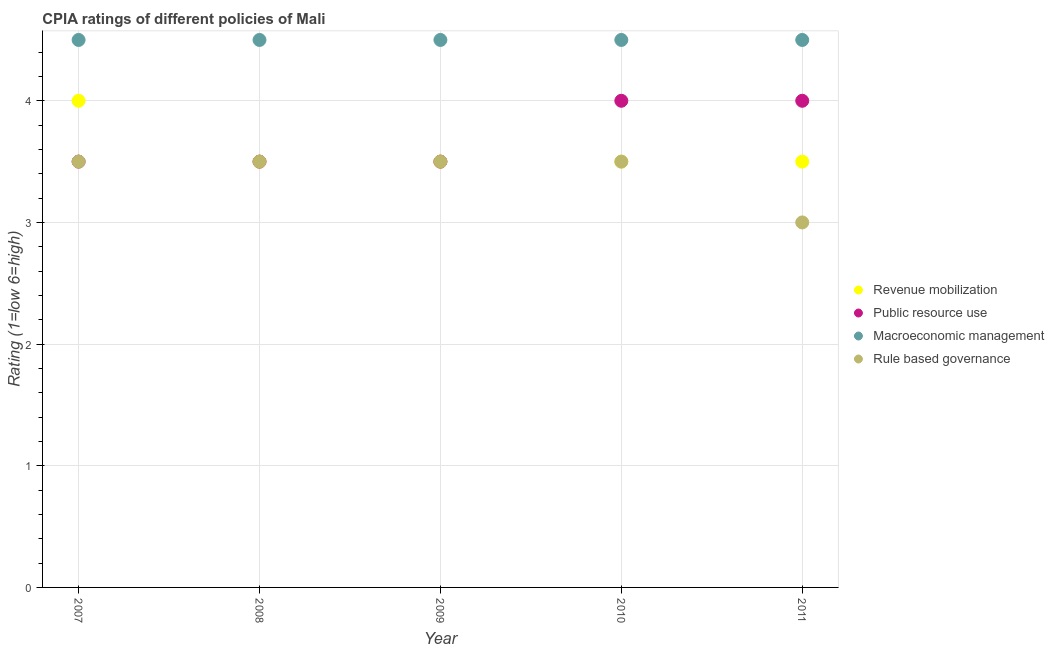What is the cpia rating of revenue mobilization in 2008?
Offer a terse response. 3.5. In which year was the cpia rating of public resource use maximum?
Make the answer very short. 2010. In which year was the cpia rating of macroeconomic management minimum?
Your answer should be very brief. 2007. What is the total cpia rating of revenue mobilization in the graph?
Give a very brief answer. 18. What is the average cpia rating of rule based governance per year?
Provide a short and direct response. 3.4. In the year 2011, what is the difference between the cpia rating of public resource use and cpia rating of macroeconomic management?
Ensure brevity in your answer.  -0.5. Is the cpia rating of public resource use in 2010 less than that in 2011?
Your response must be concise. No. Is the difference between the cpia rating of public resource use in 2008 and 2009 greater than the difference between the cpia rating of rule based governance in 2008 and 2009?
Give a very brief answer. No. What is the difference between the highest and the second highest cpia rating of public resource use?
Make the answer very short. 0. In how many years, is the cpia rating of macroeconomic management greater than the average cpia rating of macroeconomic management taken over all years?
Give a very brief answer. 0. Is the sum of the cpia rating of public resource use in 2009 and 2010 greater than the maximum cpia rating of revenue mobilization across all years?
Provide a short and direct response. Yes. Is it the case that in every year, the sum of the cpia rating of revenue mobilization and cpia rating of public resource use is greater than the cpia rating of macroeconomic management?
Your answer should be very brief. Yes. Is the cpia rating of rule based governance strictly less than the cpia rating of revenue mobilization over the years?
Provide a short and direct response. No. Are the values on the major ticks of Y-axis written in scientific E-notation?
Your answer should be compact. No. Where does the legend appear in the graph?
Make the answer very short. Center right. What is the title of the graph?
Offer a very short reply. CPIA ratings of different policies of Mali. Does "Third 20% of population" appear as one of the legend labels in the graph?
Provide a succinct answer. No. What is the label or title of the X-axis?
Offer a very short reply. Year. What is the label or title of the Y-axis?
Your answer should be compact. Rating (1=low 6=high). What is the Rating (1=low 6=high) of Revenue mobilization in 2007?
Your answer should be compact. 4. What is the Rating (1=low 6=high) in Public resource use in 2007?
Make the answer very short. 3.5. What is the Rating (1=low 6=high) of Macroeconomic management in 2007?
Provide a succinct answer. 4.5. What is the Rating (1=low 6=high) of Rule based governance in 2007?
Your response must be concise. 3.5. What is the Rating (1=low 6=high) in Revenue mobilization in 2008?
Provide a succinct answer. 3.5. What is the Rating (1=low 6=high) of Macroeconomic management in 2008?
Give a very brief answer. 4.5. What is the Rating (1=low 6=high) in Rule based governance in 2008?
Offer a very short reply. 3.5. What is the Rating (1=low 6=high) in Revenue mobilization in 2009?
Ensure brevity in your answer.  3.5. What is the Rating (1=low 6=high) in Public resource use in 2009?
Give a very brief answer. 3.5. What is the Rating (1=low 6=high) of Public resource use in 2010?
Make the answer very short. 4. What is the Rating (1=low 6=high) in Macroeconomic management in 2010?
Offer a terse response. 4.5. What is the Rating (1=low 6=high) in Rule based governance in 2010?
Your answer should be compact. 3.5. What is the Rating (1=low 6=high) in Macroeconomic management in 2011?
Your answer should be very brief. 4.5. Across all years, what is the maximum Rating (1=low 6=high) in Revenue mobilization?
Provide a short and direct response. 4. Across all years, what is the maximum Rating (1=low 6=high) in Public resource use?
Your answer should be very brief. 4. Across all years, what is the maximum Rating (1=low 6=high) in Rule based governance?
Provide a short and direct response. 3.5. Across all years, what is the minimum Rating (1=low 6=high) of Public resource use?
Your response must be concise. 3.5. Across all years, what is the minimum Rating (1=low 6=high) in Macroeconomic management?
Your answer should be compact. 4.5. What is the total Rating (1=low 6=high) of Macroeconomic management in the graph?
Keep it short and to the point. 22.5. What is the total Rating (1=low 6=high) of Rule based governance in the graph?
Your response must be concise. 17. What is the difference between the Rating (1=low 6=high) of Revenue mobilization in 2007 and that in 2008?
Your answer should be very brief. 0.5. What is the difference between the Rating (1=low 6=high) of Public resource use in 2007 and that in 2008?
Keep it short and to the point. 0. What is the difference between the Rating (1=low 6=high) of Rule based governance in 2007 and that in 2008?
Your response must be concise. 0. What is the difference between the Rating (1=low 6=high) in Revenue mobilization in 2007 and that in 2009?
Give a very brief answer. 0.5. What is the difference between the Rating (1=low 6=high) in Public resource use in 2007 and that in 2009?
Your answer should be very brief. 0. What is the difference between the Rating (1=low 6=high) in Macroeconomic management in 2007 and that in 2009?
Your response must be concise. 0. What is the difference between the Rating (1=low 6=high) of Rule based governance in 2007 and that in 2009?
Offer a terse response. 0. What is the difference between the Rating (1=low 6=high) in Public resource use in 2007 and that in 2010?
Keep it short and to the point. -0.5. What is the difference between the Rating (1=low 6=high) in Macroeconomic management in 2007 and that in 2010?
Your response must be concise. 0. What is the difference between the Rating (1=low 6=high) in Revenue mobilization in 2007 and that in 2011?
Provide a succinct answer. 0.5. What is the difference between the Rating (1=low 6=high) in Public resource use in 2007 and that in 2011?
Your response must be concise. -0.5. What is the difference between the Rating (1=low 6=high) of Revenue mobilization in 2008 and that in 2009?
Your answer should be very brief. 0. What is the difference between the Rating (1=low 6=high) of Public resource use in 2008 and that in 2009?
Your answer should be very brief. 0. What is the difference between the Rating (1=low 6=high) of Macroeconomic management in 2008 and that in 2009?
Offer a terse response. 0. What is the difference between the Rating (1=low 6=high) in Rule based governance in 2008 and that in 2009?
Provide a succinct answer. 0. What is the difference between the Rating (1=low 6=high) of Public resource use in 2008 and that in 2010?
Offer a terse response. -0.5. What is the difference between the Rating (1=low 6=high) of Macroeconomic management in 2008 and that in 2010?
Provide a short and direct response. 0. What is the difference between the Rating (1=low 6=high) of Public resource use in 2008 and that in 2011?
Provide a succinct answer. -0.5. What is the difference between the Rating (1=low 6=high) of Revenue mobilization in 2009 and that in 2010?
Your answer should be compact. 0. What is the difference between the Rating (1=low 6=high) in Public resource use in 2009 and that in 2010?
Your answer should be very brief. -0.5. What is the difference between the Rating (1=low 6=high) in Rule based governance in 2009 and that in 2010?
Provide a succinct answer. 0. What is the difference between the Rating (1=low 6=high) of Revenue mobilization in 2009 and that in 2011?
Make the answer very short. 0. What is the difference between the Rating (1=low 6=high) of Rule based governance in 2010 and that in 2011?
Ensure brevity in your answer.  0.5. What is the difference between the Rating (1=low 6=high) of Revenue mobilization in 2007 and the Rating (1=low 6=high) of Macroeconomic management in 2008?
Your answer should be compact. -0.5. What is the difference between the Rating (1=low 6=high) of Public resource use in 2007 and the Rating (1=low 6=high) of Macroeconomic management in 2008?
Your answer should be very brief. -1. What is the difference between the Rating (1=low 6=high) of Macroeconomic management in 2007 and the Rating (1=low 6=high) of Rule based governance in 2008?
Your answer should be very brief. 1. What is the difference between the Rating (1=low 6=high) of Revenue mobilization in 2007 and the Rating (1=low 6=high) of Public resource use in 2009?
Keep it short and to the point. 0.5. What is the difference between the Rating (1=low 6=high) of Public resource use in 2007 and the Rating (1=low 6=high) of Macroeconomic management in 2009?
Provide a short and direct response. -1. What is the difference between the Rating (1=low 6=high) in Public resource use in 2007 and the Rating (1=low 6=high) in Rule based governance in 2009?
Your response must be concise. 0. What is the difference between the Rating (1=low 6=high) of Revenue mobilization in 2007 and the Rating (1=low 6=high) of Macroeconomic management in 2010?
Offer a very short reply. -0.5. What is the difference between the Rating (1=low 6=high) in Revenue mobilization in 2007 and the Rating (1=low 6=high) in Rule based governance in 2010?
Provide a short and direct response. 0.5. What is the difference between the Rating (1=low 6=high) in Public resource use in 2007 and the Rating (1=low 6=high) in Macroeconomic management in 2010?
Keep it short and to the point. -1. What is the difference between the Rating (1=low 6=high) in Macroeconomic management in 2007 and the Rating (1=low 6=high) in Rule based governance in 2010?
Offer a very short reply. 1. What is the difference between the Rating (1=low 6=high) of Revenue mobilization in 2007 and the Rating (1=low 6=high) of Macroeconomic management in 2011?
Keep it short and to the point. -0.5. What is the difference between the Rating (1=low 6=high) of Public resource use in 2007 and the Rating (1=low 6=high) of Macroeconomic management in 2011?
Make the answer very short. -1. What is the difference between the Rating (1=low 6=high) of Revenue mobilization in 2008 and the Rating (1=low 6=high) of Public resource use in 2009?
Ensure brevity in your answer.  0. What is the difference between the Rating (1=low 6=high) of Revenue mobilization in 2008 and the Rating (1=low 6=high) of Macroeconomic management in 2009?
Provide a short and direct response. -1. What is the difference between the Rating (1=low 6=high) in Public resource use in 2008 and the Rating (1=low 6=high) in Macroeconomic management in 2009?
Offer a very short reply. -1. What is the difference between the Rating (1=low 6=high) of Public resource use in 2008 and the Rating (1=low 6=high) of Rule based governance in 2009?
Offer a terse response. 0. What is the difference between the Rating (1=low 6=high) of Macroeconomic management in 2008 and the Rating (1=low 6=high) of Rule based governance in 2009?
Offer a very short reply. 1. What is the difference between the Rating (1=low 6=high) of Revenue mobilization in 2008 and the Rating (1=low 6=high) of Public resource use in 2010?
Your answer should be very brief. -0.5. What is the difference between the Rating (1=low 6=high) of Public resource use in 2008 and the Rating (1=low 6=high) of Rule based governance in 2010?
Make the answer very short. 0. What is the difference between the Rating (1=low 6=high) in Revenue mobilization in 2008 and the Rating (1=low 6=high) in Macroeconomic management in 2011?
Provide a short and direct response. -1. What is the difference between the Rating (1=low 6=high) of Public resource use in 2008 and the Rating (1=low 6=high) of Macroeconomic management in 2011?
Your response must be concise. -1. What is the difference between the Rating (1=low 6=high) in Public resource use in 2008 and the Rating (1=low 6=high) in Rule based governance in 2011?
Give a very brief answer. 0.5. What is the difference between the Rating (1=low 6=high) in Revenue mobilization in 2009 and the Rating (1=low 6=high) in Macroeconomic management in 2010?
Ensure brevity in your answer.  -1. What is the difference between the Rating (1=low 6=high) of Revenue mobilization in 2009 and the Rating (1=low 6=high) of Rule based governance in 2010?
Your response must be concise. 0. What is the difference between the Rating (1=low 6=high) of Public resource use in 2009 and the Rating (1=low 6=high) of Macroeconomic management in 2010?
Keep it short and to the point. -1. What is the difference between the Rating (1=low 6=high) of Macroeconomic management in 2009 and the Rating (1=low 6=high) of Rule based governance in 2010?
Offer a terse response. 1. What is the difference between the Rating (1=low 6=high) of Revenue mobilization in 2009 and the Rating (1=low 6=high) of Public resource use in 2011?
Provide a succinct answer. -0.5. What is the difference between the Rating (1=low 6=high) of Revenue mobilization in 2009 and the Rating (1=low 6=high) of Macroeconomic management in 2011?
Provide a short and direct response. -1. What is the difference between the Rating (1=low 6=high) of Revenue mobilization in 2009 and the Rating (1=low 6=high) of Rule based governance in 2011?
Your answer should be very brief. 0.5. What is the difference between the Rating (1=low 6=high) in Revenue mobilization in 2010 and the Rating (1=low 6=high) in Rule based governance in 2011?
Ensure brevity in your answer.  0.5. What is the difference between the Rating (1=low 6=high) of Public resource use in 2010 and the Rating (1=low 6=high) of Rule based governance in 2011?
Provide a succinct answer. 1. What is the difference between the Rating (1=low 6=high) in Macroeconomic management in 2010 and the Rating (1=low 6=high) in Rule based governance in 2011?
Provide a short and direct response. 1.5. What is the average Rating (1=low 6=high) in Macroeconomic management per year?
Offer a terse response. 4.5. What is the average Rating (1=low 6=high) in Rule based governance per year?
Keep it short and to the point. 3.4. In the year 2007, what is the difference between the Rating (1=low 6=high) in Revenue mobilization and Rating (1=low 6=high) in Public resource use?
Provide a succinct answer. 0.5. In the year 2007, what is the difference between the Rating (1=low 6=high) of Public resource use and Rating (1=low 6=high) of Macroeconomic management?
Keep it short and to the point. -1. In the year 2008, what is the difference between the Rating (1=low 6=high) in Revenue mobilization and Rating (1=low 6=high) in Rule based governance?
Your answer should be very brief. 0. In the year 2008, what is the difference between the Rating (1=low 6=high) in Public resource use and Rating (1=low 6=high) in Rule based governance?
Provide a short and direct response. 0. In the year 2009, what is the difference between the Rating (1=low 6=high) in Revenue mobilization and Rating (1=low 6=high) in Public resource use?
Provide a succinct answer. 0. In the year 2009, what is the difference between the Rating (1=low 6=high) in Revenue mobilization and Rating (1=low 6=high) in Macroeconomic management?
Provide a short and direct response. -1. In the year 2009, what is the difference between the Rating (1=low 6=high) in Revenue mobilization and Rating (1=low 6=high) in Rule based governance?
Your answer should be compact. 0. In the year 2009, what is the difference between the Rating (1=low 6=high) of Public resource use and Rating (1=low 6=high) of Macroeconomic management?
Make the answer very short. -1. In the year 2009, what is the difference between the Rating (1=low 6=high) in Public resource use and Rating (1=low 6=high) in Rule based governance?
Offer a terse response. 0. In the year 2010, what is the difference between the Rating (1=low 6=high) in Revenue mobilization and Rating (1=low 6=high) in Rule based governance?
Provide a short and direct response. 0. In the year 2010, what is the difference between the Rating (1=low 6=high) of Public resource use and Rating (1=low 6=high) of Macroeconomic management?
Your answer should be compact. -0.5. In the year 2011, what is the difference between the Rating (1=low 6=high) of Revenue mobilization and Rating (1=low 6=high) of Macroeconomic management?
Provide a succinct answer. -1. In the year 2011, what is the difference between the Rating (1=low 6=high) of Revenue mobilization and Rating (1=low 6=high) of Rule based governance?
Provide a succinct answer. 0.5. In the year 2011, what is the difference between the Rating (1=low 6=high) in Public resource use and Rating (1=low 6=high) in Macroeconomic management?
Your answer should be compact. -0.5. In the year 2011, what is the difference between the Rating (1=low 6=high) in Public resource use and Rating (1=low 6=high) in Rule based governance?
Provide a succinct answer. 1. In the year 2011, what is the difference between the Rating (1=low 6=high) of Macroeconomic management and Rating (1=low 6=high) of Rule based governance?
Give a very brief answer. 1.5. What is the ratio of the Rating (1=low 6=high) of Public resource use in 2007 to that in 2008?
Offer a very short reply. 1. What is the ratio of the Rating (1=low 6=high) of Revenue mobilization in 2007 to that in 2009?
Provide a succinct answer. 1.14. What is the ratio of the Rating (1=low 6=high) in Rule based governance in 2007 to that in 2009?
Your answer should be very brief. 1. What is the ratio of the Rating (1=low 6=high) of Public resource use in 2007 to that in 2010?
Your answer should be compact. 0.88. What is the ratio of the Rating (1=low 6=high) in Macroeconomic management in 2007 to that in 2010?
Keep it short and to the point. 1. What is the ratio of the Rating (1=low 6=high) in Rule based governance in 2007 to that in 2010?
Provide a short and direct response. 1. What is the ratio of the Rating (1=low 6=high) of Revenue mobilization in 2007 to that in 2011?
Keep it short and to the point. 1.14. What is the ratio of the Rating (1=low 6=high) in Macroeconomic management in 2007 to that in 2011?
Make the answer very short. 1. What is the ratio of the Rating (1=low 6=high) in Macroeconomic management in 2008 to that in 2009?
Ensure brevity in your answer.  1. What is the ratio of the Rating (1=low 6=high) in Revenue mobilization in 2008 to that in 2010?
Ensure brevity in your answer.  1. What is the ratio of the Rating (1=low 6=high) in Public resource use in 2008 to that in 2010?
Ensure brevity in your answer.  0.88. What is the ratio of the Rating (1=low 6=high) of Rule based governance in 2008 to that in 2011?
Offer a very short reply. 1.17. What is the ratio of the Rating (1=low 6=high) of Revenue mobilization in 2009 to that in 2010?
Your answer should be very brief. 1. What is the ratio of the Rating (1=low 6=high) in Public resource use in 2009 to that in 2010?
Give a very brief answer. 0.88. What is the ratio of the Rating (1=low 6=high) of Macroeconomic management in 2009 to that in 2010?
Offer a very short reply. 1. What is the ratio of the Rating (1=low 6=high) of Revenue mobilization in 2009 to that in 2011?
Your answer should be very brief. 1. What is the ratio of the Rating (1=low 6=high) in Macroeconomic management in 2009 to that in 2011?
Your response must be concise. 1. What is the ratio of the Rating (1=low 6=high) in Public resource use in 2010 to that in 2011?
Offer a very short reply. 1. What is the difference between the highest and the second highest Rating (1=low 6=high) in Macroeconomic management?
Give a very brief answer. 0. What is the difference between the highest and the lowest Rating (1=low 6=high) in Revenue mobilization?
Make the answer very short. 0.5. What is the difference between the highest and the lowest Rating (1=low 6=high) of Public resource use?
Offer a very short reply. 0.5. 